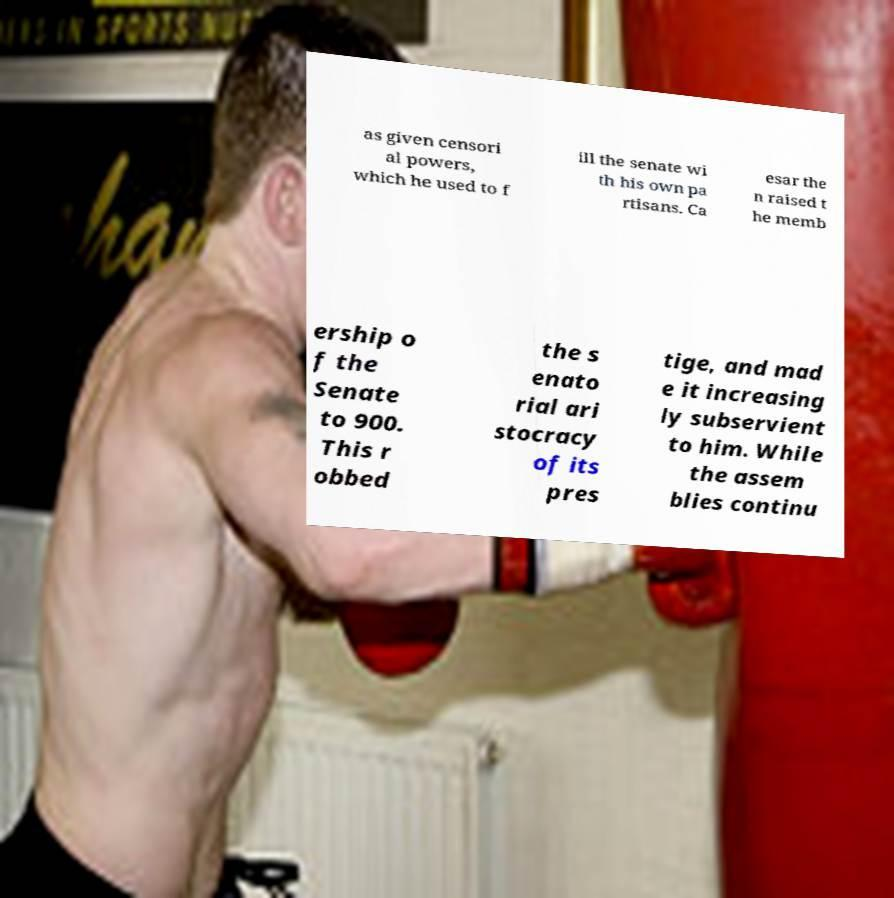Please read and relay the text visible in this image. What does it say? as given censori al powers, which he used to f ill the senate wi th his own pa rtisans. Ca esar the n raised t he memb ership o f the Senate to 900. This r obbed the s enato rial ari stocracy of its pres tige, and mad e it increasing ly subservient to him. While the assem blies continu 